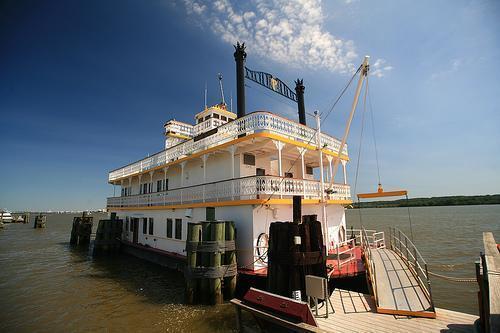How many smokestacks does the boat have?
Give a very brief answer. 2. 